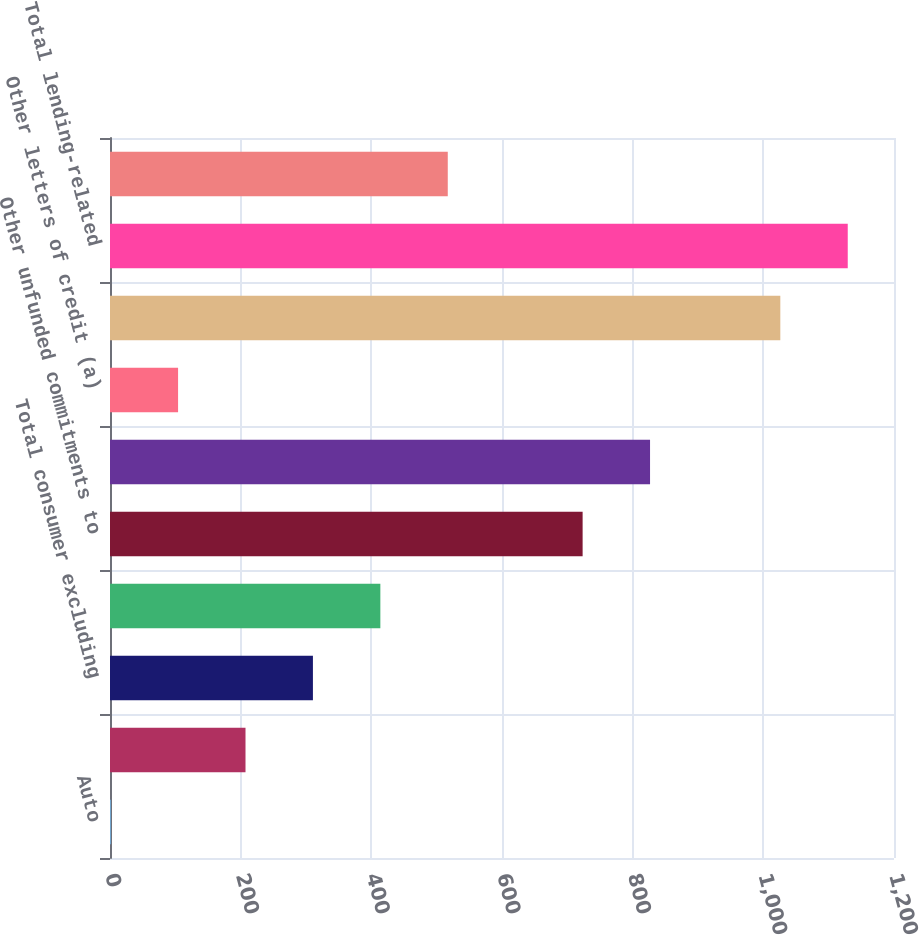<chart> <loc_0><loc_0><loc_500><loc_500><bar_chart><fcel>Auto<fcel>Business banking<fcel>Total consumer excluding<fcel>Total consumer<fcel>Other unfunded commitments to<fcel>Standby letters of credit and<fcel>Other letters of credit (a)<fcel>Total wholesale<fcel>Total lending-related<fcel>Derivatives qualifying as<nl><fcel>1<fcel>207.4<fcel>310.6<fcel>413.8<fcel>723.4<fcel>826.6<fcel>104.2<fcel>1026<fcel>1129.2<fcel>517<nl></chart> 